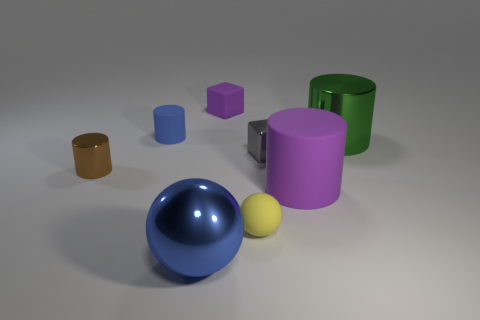Add 1 tiny purple cubes. How many objects exist? 9 Subtract all cubes. How many objects are left? 6 Add 1 matte balls. How many matte balls exist? 2 Subtract 1 yellow balls. How many objects are left? 7 Subtract all small matte cylinders. Subtract all yellow matte balls. How many objects are left? 6 Add 1 small shiny cylinders. How many small shiny cylinders are left? 2 